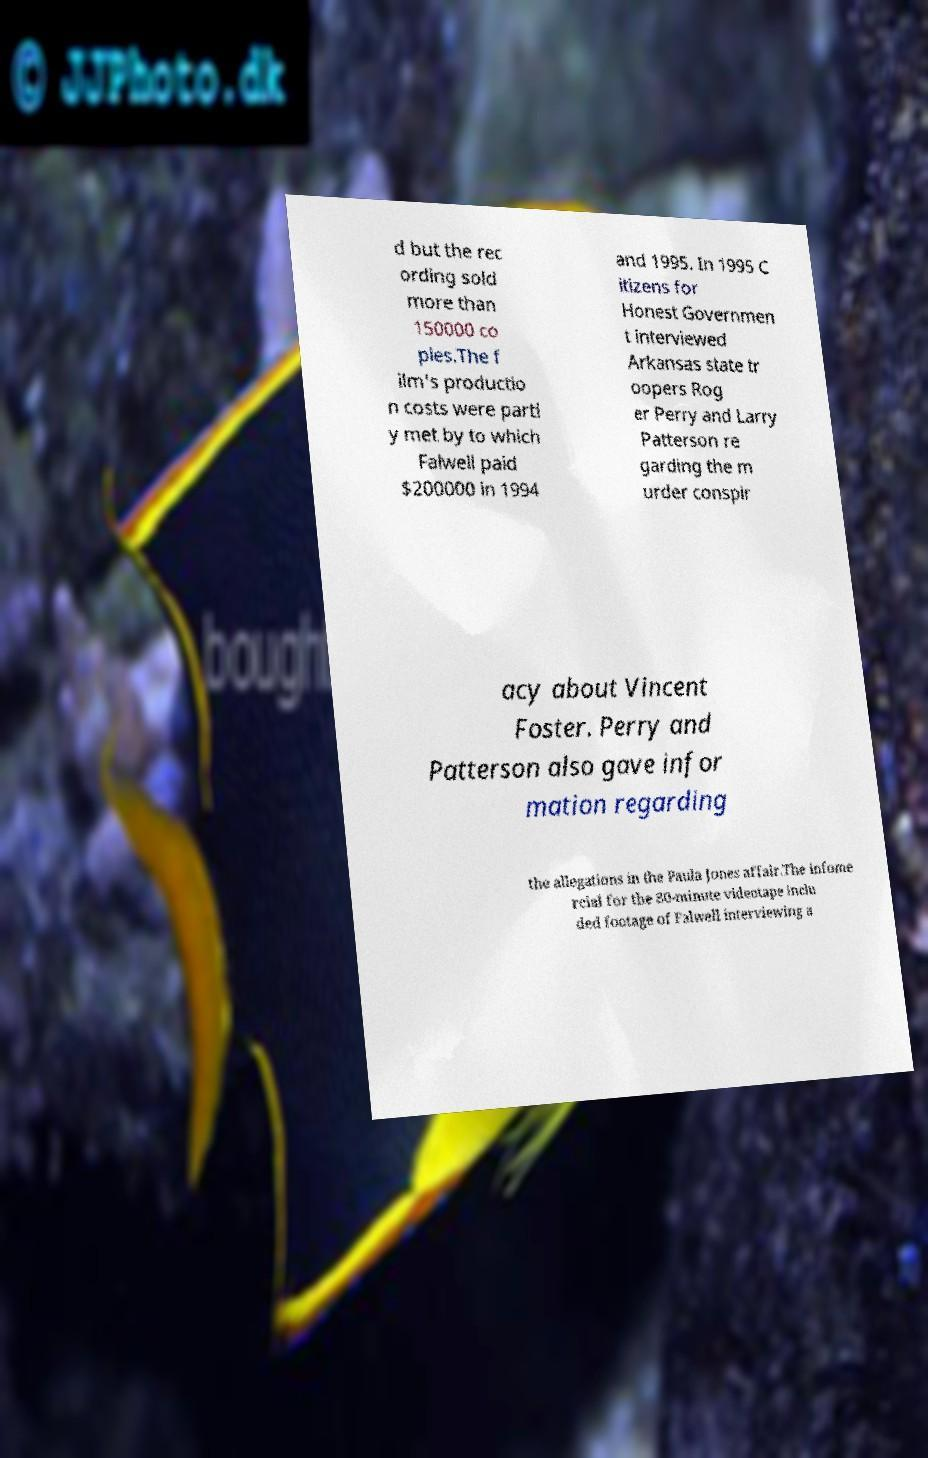Can you read and provide the text displayed in the image?This photo seems to have some interesting text. Can you extract and type it out for me? d but the rec ording sold more than 150000 co pies.The f ilm's productio n costs were partl y met by to which Falwell paid $200000 in 1994 and 1995. In 1995 C itizens for Honest Governmen t interviewed Arkansas state tr oopers Rog er Perry and Larry Patterson re garding the m urder conspir acy about Vincent Foster. Perry and Patterson also gave infor mation regarding the allegations in the Paula Jones affair.The infome rcial for the 80-minute videotape inclu ded footage of Falwell interviewing a 